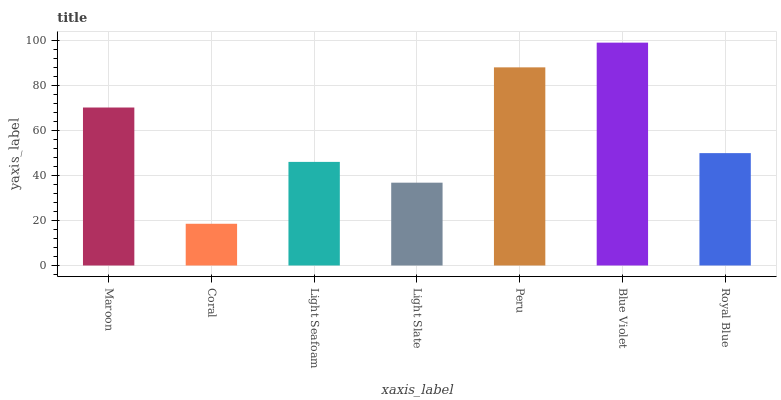Is Coral the minimum?
Answer yes or no. Yes. Is Blue Violet the maximum?
Answer yes or no. Yes. Is Light Seafoam the minimum?
Answer yes or no. No. Is Light Seafoam the maximum?
Answer yes or no. No. Is Light Seafoam greater than Coral?
Answer yes or no. Yes. Is Coral less than Light Seafoam?
Answer yes or no. Yes. Is Coral greater than Light Seafoam?
Answer yes or no. No. Is Light Seafoam less than Coral?
Answer yes or no. No. Is Royal Blue the high median?
Answer yes or no. Yes. Is Royal Blue the low median?
Answer yes or no. Yes. Is Light Slate the high median?
Answer yes or no. No. Is Light Slate the low median?
Answer yes or no. No. 